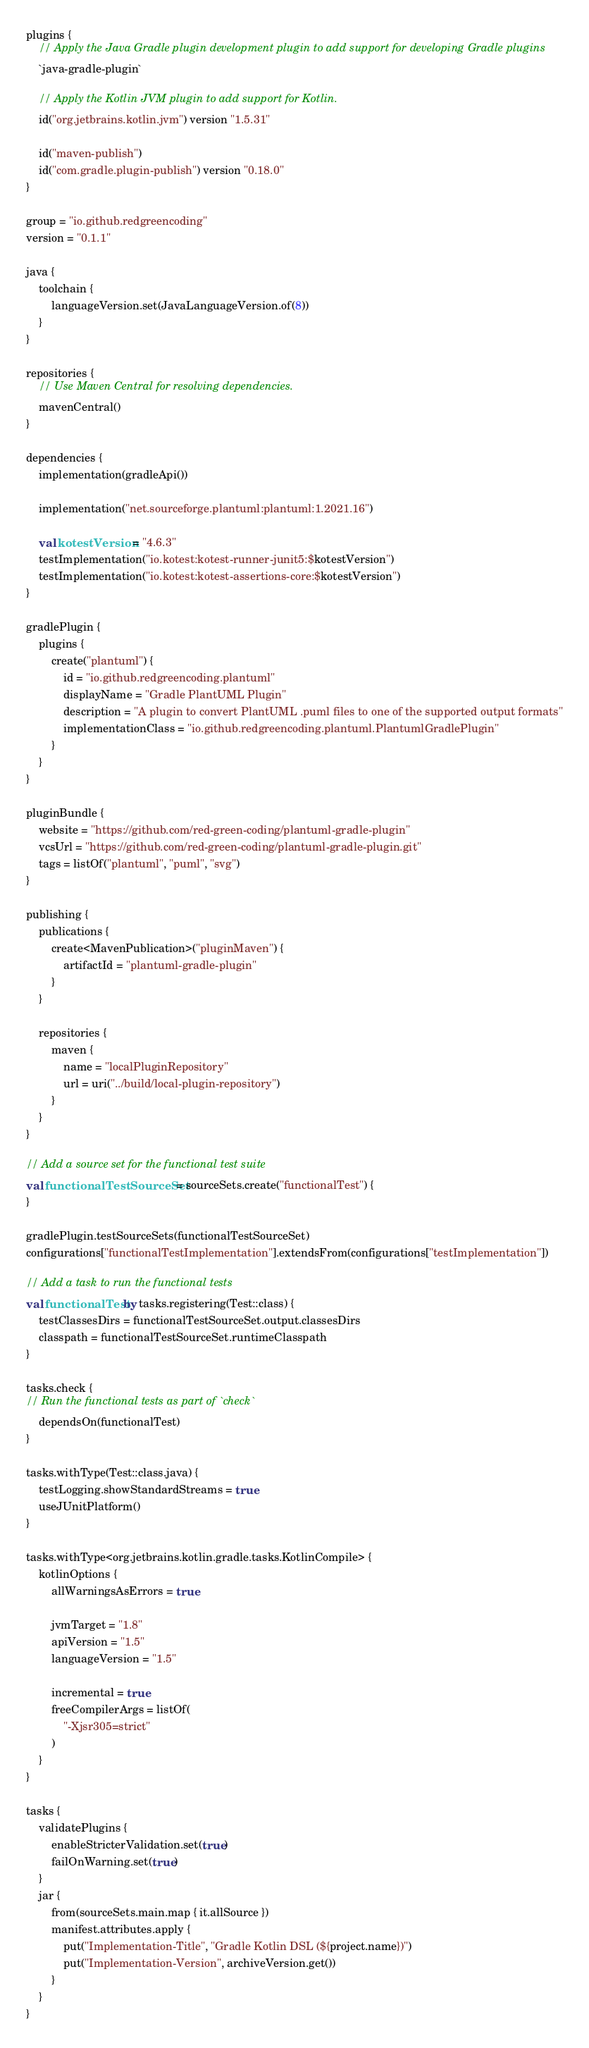<code> <loc_0><loc_0><loc_500><loc_500><_Kotlin_>plugins {
    // Apply the Java Gradle plugin development plugin to add support for developing Gradle plugins
    `java-gradle-plugin`

    // Apply the Kotlin JVM plugin to add support for Kotlin.
    id("org.jetbrains.kotlin.jvm") version "1.5.31"

    id("maven-publish")
    id("com.gradle.plugin-publish") version "0.18.0"
}

group = "io.github.redgreencoding"
version = "0.1.1"

java {
    toolchain {
        languageVersion.set(JavaLanguageVersion.of(8))
    }
}

repositories {
    // Use Maven Central for resolving dependencies.
    mavenCentral()
}

dependencies {
    implementation(gradleApi())

    implementation("net.sourceforge.plantuml:plantuml:1.2021.16")

    val kotestVersion = "4.6.3"
    testImplementation("io.kotest:kotest-runner-junit5:$kotestVersion")
    testImplementation("io.kotest:kotest-assertions-core:$kotestVersion")
}

gradlePlugin {
    plugins {
        create("plantuml") {
            id = "io.github.redgreencoding.plantuml"
            displayName = "Gradle PlantUML Plugin"
            description = "A plugin to convert PlantUML .puml files to one of the supported output formats"
            implementationClass = "io.github.redgreencoding.plantuml.PlantumlGradlePlugin"
        }
    }
}

pluginBundle {
    website = "https://github.com/red-green-coding/plantuml-gradle-plugin"
    vcsUrl = "https://github.com/red-green-coding/plantuml-gradle-plugin.git"
    tags = listOf("plantuml", "puml", "svg")
}

publishing {
    publications {
        create<MavenPublication>("pluginMaven") {
            artifactId = "plantuml-gradle-plugin"
        }
    }

    repositories {
        maven {
            name = "localPluginRepository"
            url = uri("../build/local-plugin-repository")
        }
    }
}

// Add a source set for the functional test suite
val functionalTestSourceSet = sourceSets.create("functionalTest") {
}

gradlePlugin.testSourceSets(functionalTestSourceSet)
configurations["functionalTestImplementation"].extendsFrom(configurations["testImplementation"])

// Add a task to run the functional tests
val functionalTest by tasks.registering(Test::class) {
    testClassesDirs = functionalTestSourceSet.output.classesDirs
    classpath = functionalTestSourceSet.runtimeClasspath
}

tasks.check {
// Run the functional tests as part of `check`
    dependsOn(functionalTest)
}

tasks.withType(Test::class.java) {
    testLogging.showStandardStreams = true
    useJUnitPlatform()
}

tasks.withType<org.jetbrains.kotlin.gradle.tasks.KotlinCompile> {
    kotlinOptions {
        allWarningsAsErrors = true

        jvmTarget = "1.8"
        apiVersion = "1.5"
        languageVersion = "1.5"

        incremental = true
        freeCompilerArgs = listOf(
            "-Xjsr305=strict"
        )
    }
}

tasks {
    validatePlugins {
        enableStricterValidation.set(true)
        failOnWarning.set(true)
    }
    jar {
        from(sourceSets.main.map { it.allSource })
        manifest.attributes.apply {
            put("Implementation-Title", "Gradle Kotlin DSL (${project.name})")
            put("Implementation-Version", archiveVersion.get())
        }
    }
}
</code> 